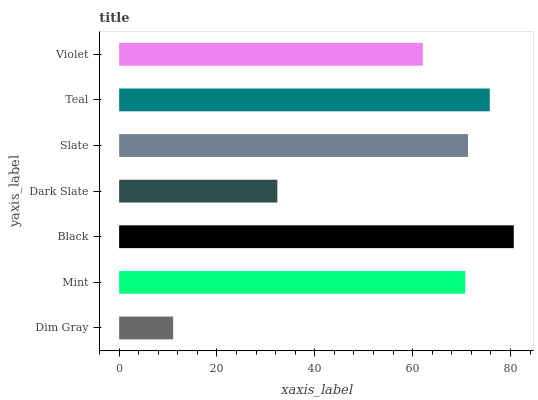Is Dim Gray the minimum?
Answer yes or no. Yes. Is Black the maximum?
Answer yes or no. Yes. Is Mint the minimum?
Answer yes or no. No. Is Mint the maximum?
Answer yes or no. No. Is Mint greater than Dim Gray?
Answer yes or no. Yes. Is Dim Gray less than Mint?
Answer yes or no. Yes. Is Dim Gray greater than Mint?
Answer yes or no. No. Is Mint less than Dim Gray?
Answer yes or no. No. Is Mint the high median?
Answer yes or no. Yes. Is Mint the low median?
Answer yes or no. Yes. Is Teal the high median?
Answer yes or no. No. Is Teal the low median?
Answer yes or no. No. 